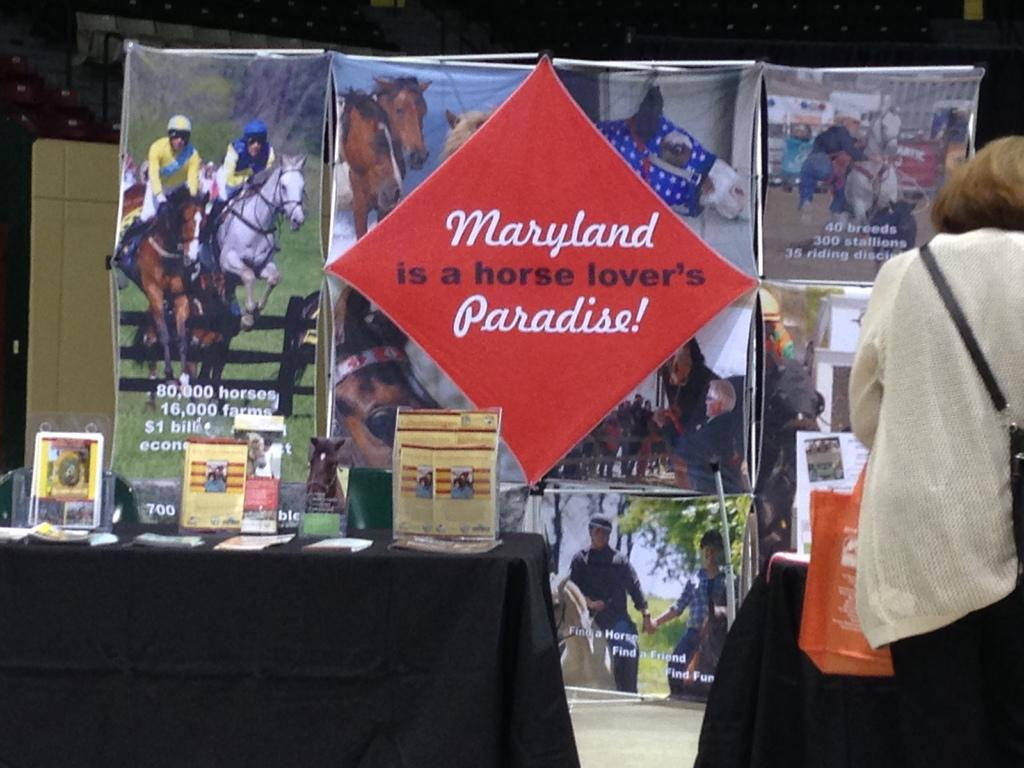<image>
Create a compact narrative representing the image presented. A sign at a display says Maryland is a horse lover's paradise. 